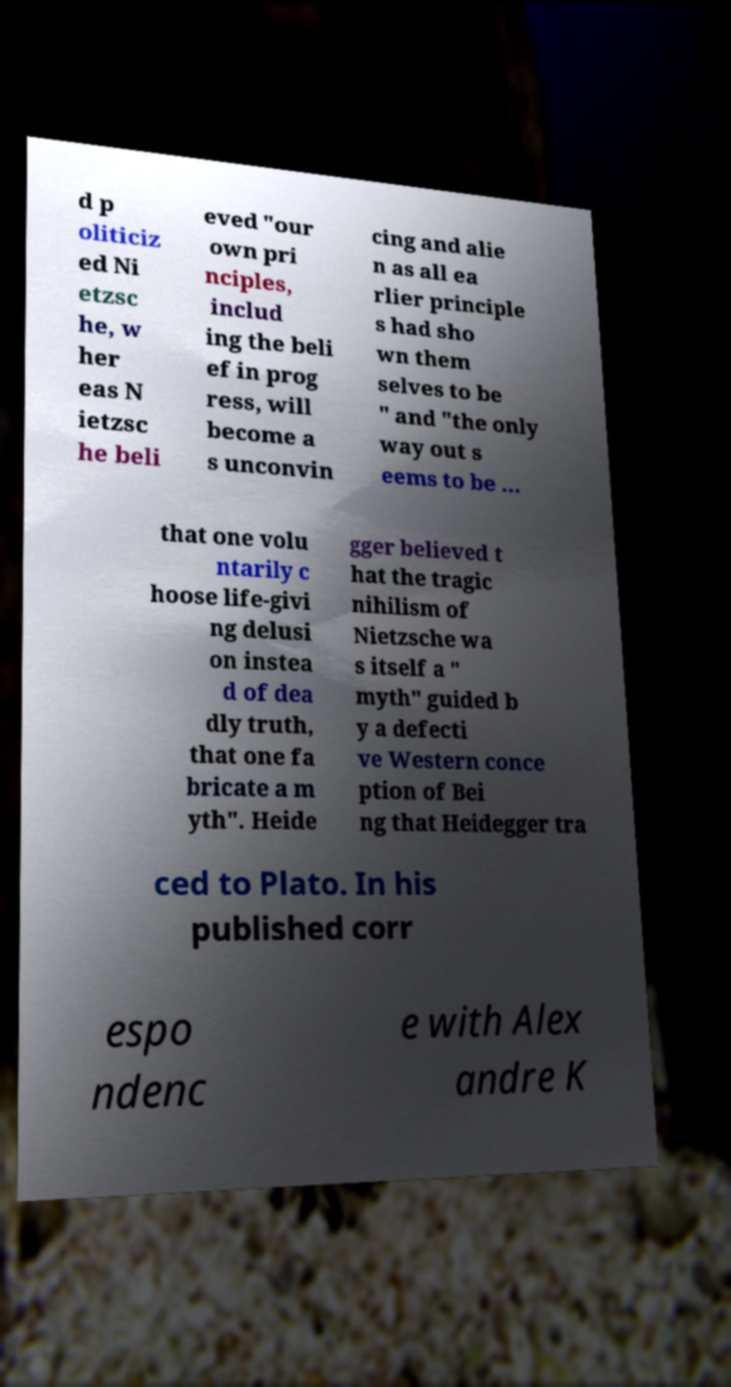Please identify and transcribe the text found in this image. d p oliticiz ed Ni etzsc he, w her eas N ietzsc he beli eved "our own pri nciples, includ ing the beli ef in prog ress, will become a s unconvin cing and alie n as all ea rlier principle s had sho wn them selves to be " and "the only way out s eems to be ... that one volu ntarily c hoose life-givi ng delusi on instea d of dea dly truth, that one fa bricate a m yth". Heide gger believed t hat the tragic nihilism of Nietzsche wa s itself a " myth" guided b y a defecti ve Western conce ption of Bei ng that Heidegger tra ced to Plato. In his published corr espo ndenc e with Alex andre K 